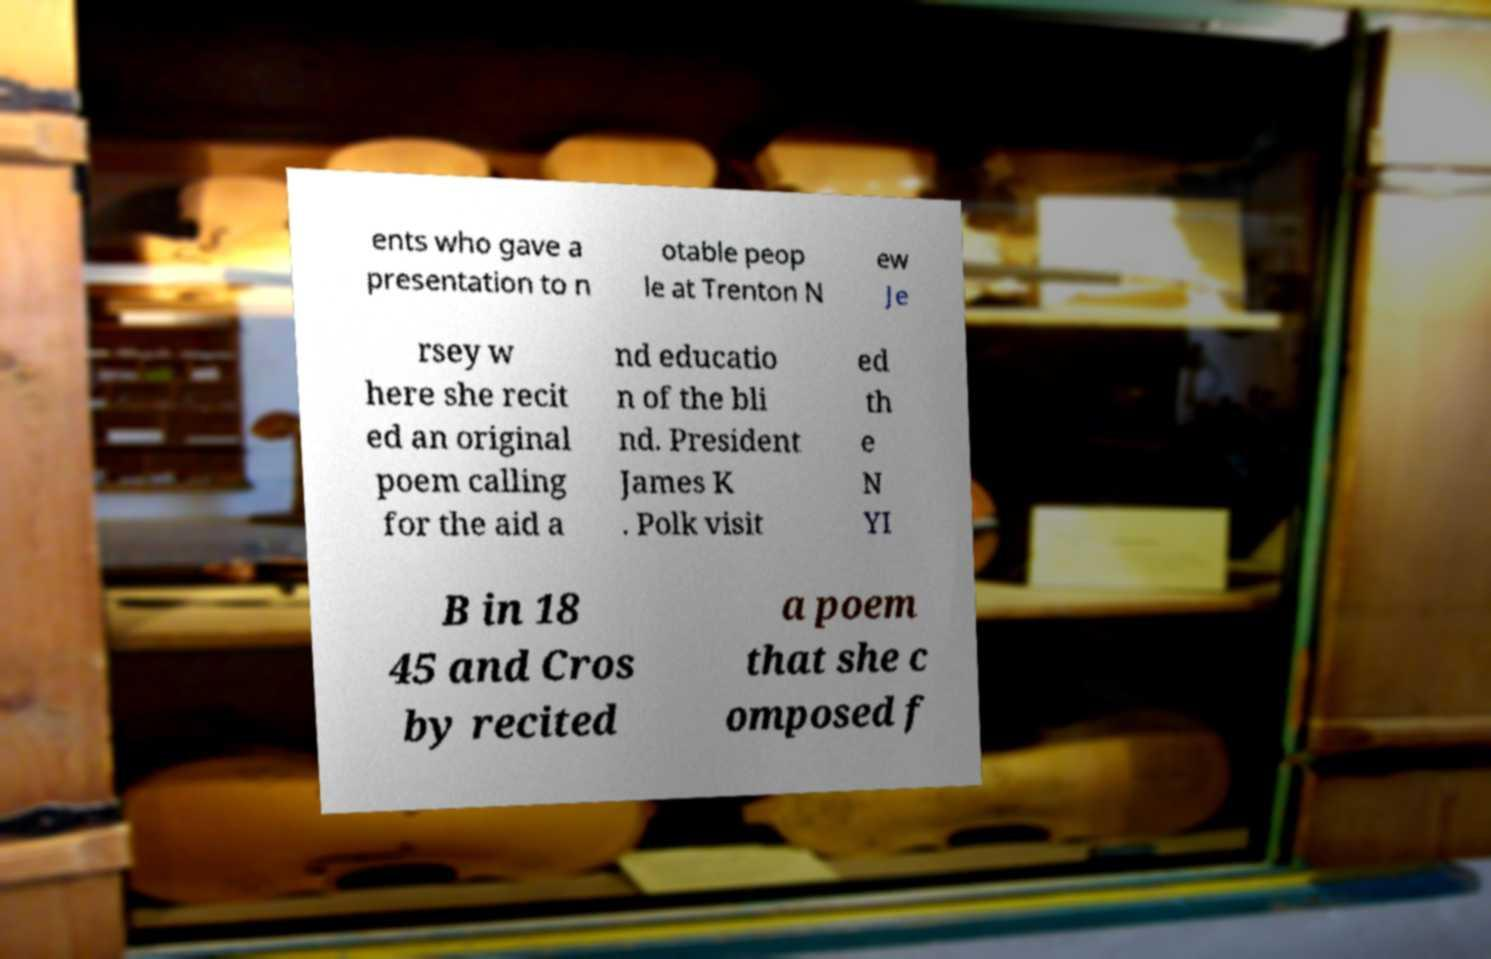Please read and relay the text visible in this image. What does it say? ents who gave a presentation to n otable peop le at Trenton N ew Je rsey w here she recit ed an original poem calling for the aid a nd educatio n of the bli nd. President James K . Polk visit ed th e N YI B in 18 45 and Cros by recited a poem that she c omposed f 